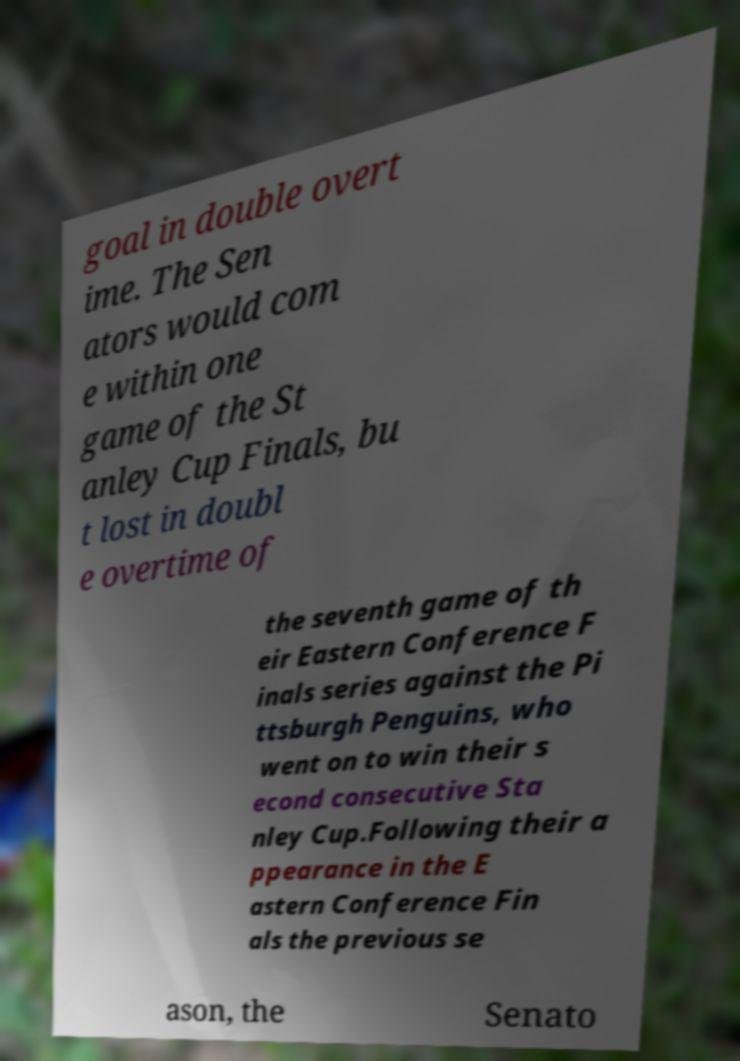I need the written content from this picture converted into text. Can you do that? goal in double overt ime. The Sen ators would com e within one game of the St anley Cup Finals, bu t lost in doubl e overtime of the seventh game of th eir Eastern Conference F inals series against the Pi ttsburgh Penguins, who went on to win their s econd consecutive Sta nley Cup.Following their a ppearance in the E astern Conference Fin als the previous se ason, the Senato 